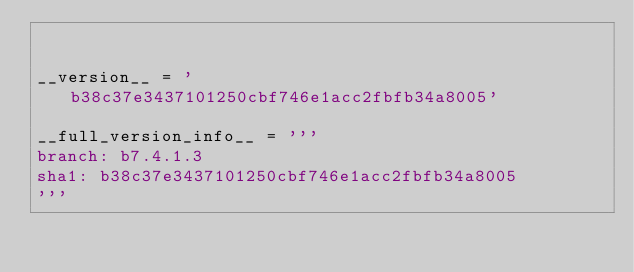Convert code to text. <code><loc_0><loc_0><loc_500><loc_500><_Python_>

__version__ = 'b38c37e3437101250cbf746e1acc2fbfb34a8005'

__full_version_info__ = '''
branch: b7.4.1.3
sha1: b38c37e3437101250cbf746e1acc2fbfb34a8005
'''
    </code> 